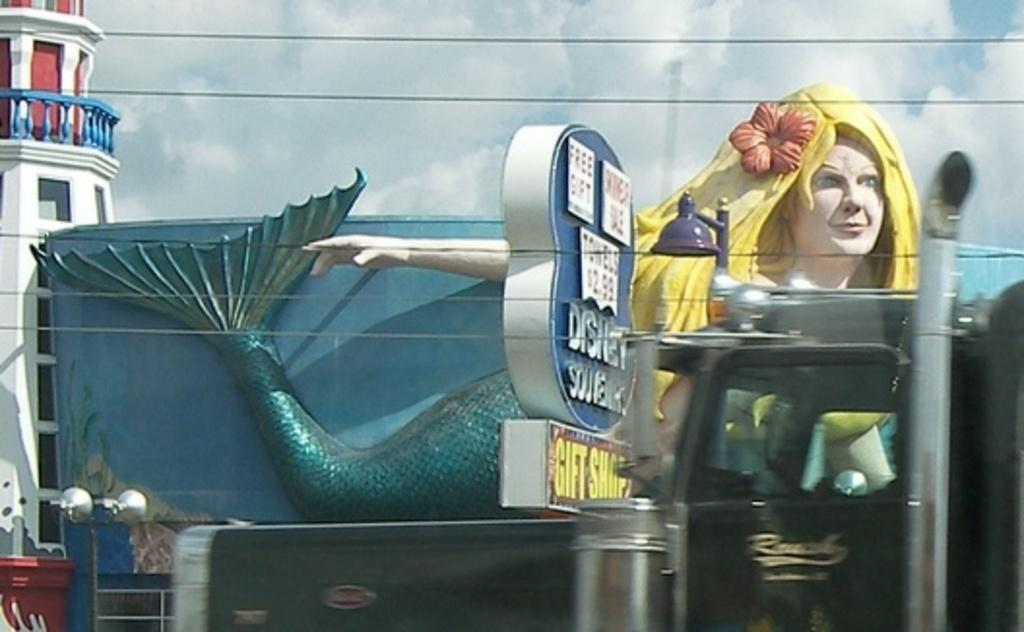What is the main subject in the image? There is a vehicle in the image. What can be seen near the vehicle? There are hoardings and lights near the vehicle. Are there any other visible elements in the image? Yes, there are cables visible in the image. What type of structure is present in the image? There is a building in the image. What is the effect of the organization on the heart in the image? There is no organization or heart present in the image. 